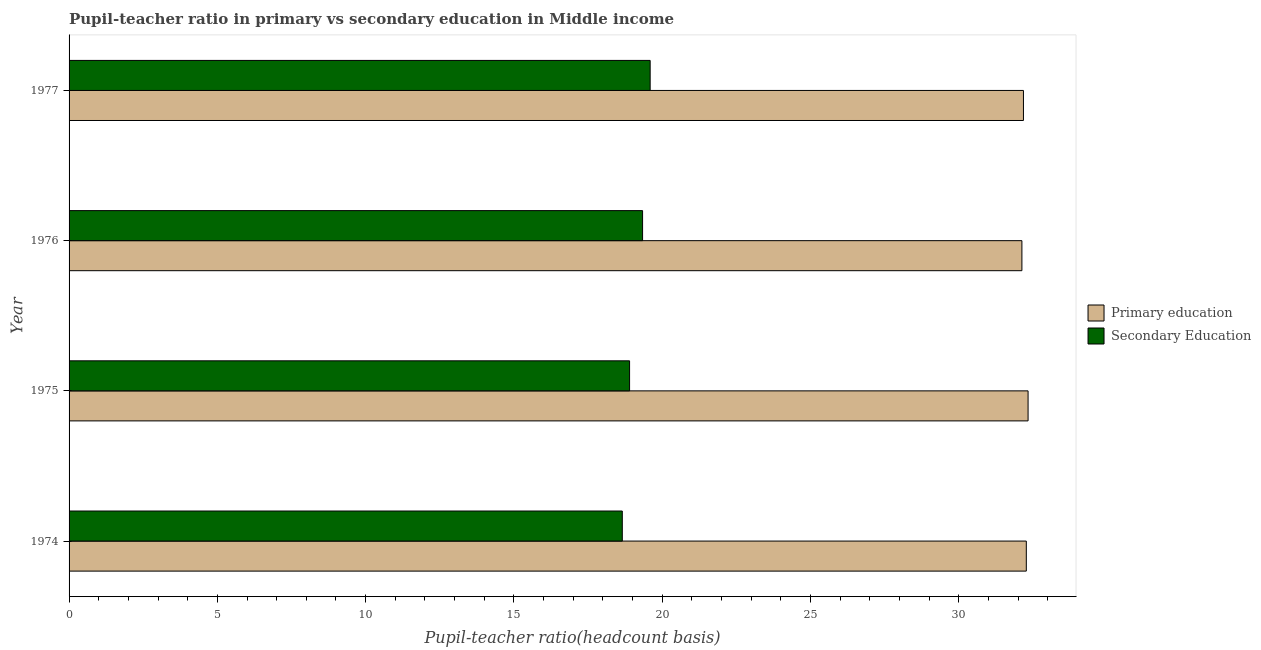How many different coloured bars are there?
Offer a terse response. 2. How many groups of bars are there?
Ensure brevity in your answer.  4. Are the number of bars per tick equal to the number of legend labels?
Your response must be concise. Yes. Are the number of bars on each tick of the Y-axis equal?
Provide a succinct answer. Yes. How many bars are there on the 3rd tick from the top?
Your response must be concise. 2. What is the label of the 3rd group of bars from the top?
Your response must be concise. 1975. What is the pupil-teacher ratio in primary education in 1977?
Ensure brevity in your answer.  32.18. Across all years, what is the maximum pupil-teacher ratio in primary education?
Your answer should be very brief. 32.34. Across all years, what is the minimum pupil-teacher ratio in primary education?
Provide a short and direct response. 32.13. In which year was the pupil teacher ratio on secondary education maximum?
Offer a very short reply. 1977. In which year was the pupil-teacher ratio in primary education minimum?
Make the answer very short. 1976. What is the total pupil teacher ratio on secondary education in the graph?
Provide a succinct answer. 76.49. What is the difference between the pupil teacher ratio on secondary education in 1975 and that in 1976?
Provide a succinct answer. -0.44. What is the difference between the pupil teacher ratio on secondary education in 1975 and the pupil-teacher ratio in primary education in 1974?
Your answer should be compact. -13.38. What is the average pupil-teacher ratio in primary education per year?
Give a very brief answer. 32.23. In the year 1976, what is the difference between the pupil-teacher ratio in primary education and pupil teacher ratio on secondary education?
Keep it short and to the point. 12.79. What is the difference between the highest and the second highest pupil teacher ratio on secondary education?
Provide a succinct answer. 0.26. What does the 2nd bar from the top in 1976 represents?
Offer a very short reply. Primary education. What does the 2nd bar from the bottom in 1975 represents?
Offer a terse response. Secondary Education. Are all the bars in the graph horizontal?
Provide a succinct answer. Yes. What is the difference between two consecutive major ticks on the X-axis?
Your answer should be compact. 5. Does the graph contain any zero values?
Your response must be concise. No. Does the graph contain grids?
Keep it short and to the point. No. How are the legend labels stacked?
Provide a succinct answer. Vertical. What is the title of the graph?
Give a very brief answer. Pupil-teacher ratio in primary vs secondary education in Middle income. Does "Under-five" appear as one of the legend labels in the graph?
Offer a terse response. No. What is the label or title of the X-axis?
Provide a succinct answer. Pupil-teacher ratio(headcount basis). What is the label or title of the Y-axis?
Provide a succinct answer. Year. What is the Pupil-teacher ratio(headcount basis) of Primary education in 1974?
Your answer should be very brief. 32.28. What is the Pupil-teacher ratio(headcount basis) in Secondary Education in 1974?
Make the answer very short. 18.66. What is the Pupil-teacher ratio(headcount basis) of Primary education in 1975?
Provide a succinct answer. 32.34. What is the Pupil-teacher ratio(headcount basis) in Secondary Education in 1975?
Provide a short and direct response. 18.9. What is the Pupil-teacher ratio(headcount basis) in Primary education in 1976?
Provide a succinct answer. 32.13. What is the Pupil-teacher ratio(headcount basis) in Secondary Education in 1976?
Keep it short and to the point. 19.34. What is the Pupil-teacher ratio(headcount basis) of Primary education in 1977?
Keep it short and to the point. 32.18. What is the Pupil-teacher ratio(headcount basis) in Secondary Education in 1977?
Your answer should be compact. 19.59. Across all years, what is the maximum Pupil-teacher ratio(headcount basis) of Primary education?
Give a very brief answer. 32.34. Across all years, what is the maximum Pupil-teacher ratio(headcount basis) in Secondary Education?
Your answer should be very brief. 19.59. Across all years, what is the minimum Pupil-teacher ratio(headcount basis) of Primary education?
Make the answer very short. 32.13. Across all years, what is the minimum Pupil-teacher ratio(headcount basis) of Secondary Education?
Ensure brevity in your answer.  18.66. What is the total Pupil-teacher ratio(headcount basis) of Primary education in the graph?
Your answer should be very brief. 128.93. What is the total Pupil-teacher ratio(headcount basis) of Secondary Education in the graph?
Ensure brevity in your answer.  76.49. What is the difference between the Pupil-teacher ratio(headcount basis) in Primary education in 1974 and that in 1975?
Make the answer very short. -0.06. What is the difference between the Pupil-teacher ratio(headcount basis) of Secondary Education in 1974 and that in 1975?
Your response must be concise. -0.25. What is the difference between the Pupil-teacher ratio(headcount basis) in Primary education in 1974 and that in 1976?
Keep it short and to the point. 0.15. What is the difference between the Pupil-teacher ratio(headcount basis) in Secondary Education in 1974 and that in 1976?
Provide a succinct answer. -0.68. What is the difference between the Pupil-teacher ratio(headcount basis) of Primary education in 1974 and that in 1977?
Ensure brevity in your answer.  0.1. What is the difference between the Pupil-teacher ratio(headcount basis) in Secondary Education in 1974 and that in 1977?
Make the answer very short. -0.94. What is the difference between the Pupil-teacher ratio(headcount basis) in Primary education in 1975 and that in 1976?
Make the answer very short. 0.21. What is the difference between the Pupil-teacher ratio(headcount basis) of Secondary Education in 1975 and that in 1976?
Your answer should be very brief. -0.44. What is the difference between the Pupil-teacher ratio(headcount basis) in Primary education in 1975 and that in 1977?
Ensure brevity in your answer.  0.16. What is the difference between the Pupil-teacher ratio(headcount basis) in Secondary Education in 1975 and that in 1977?
Provide a succinct answer. -0.69. What is the difference between the Pupil-teacher ratio(headcount basis) of Primary education in 1976 and that in 1977?
Ensure brevity in your answer.  -0.05. What is the difference between the Pupil-teacher ratio(headcount basis) of Secondary Education in 1976 and that in 1977?
Ensure brevity in your answer.  -0.26. What is the difference between the Pupil-teacher ratio(headcount basis) in Primary education in 1974 and the Pupil-teacher ratio(headcount basis) in Secondary Education in 1975?
Offer a terse response. 13.38. What is the difference between the Pupil-teacher ratio(headcount basis) in Primary education in 1974 and the Pupil-teacher ratio(headcount basis) in Secondary Education in 1976?
Provide a succinct answer. 12.94. What is the difference between the Pupil-teacher ratio(headcount basis) in Primary education in 1974 and the Pupil-teacher ratio(headcount basis) in Secondary Education in 1977?
Your response must be concise. 12.68. What is the difference between the Pupil-teacher ratio(headcount basis) in Primary education in 1975 and the Pupil-teacher ratio(headcount basis) in Secondary Education in 1976?
Keep it short and to the point. 13. What is the difference between the Pupil-teacher ratio(headcount basis) in Primary education in 1975 and the Pupil-teacher ratio(headcount basis) in Secondary Education in 1977?
Offer a very short reply. 12.74. What is the difference between the Pupil-teacher ratio(headcount basis) of Primary education in 1976 and the Pupil-teacher ratio(headcount basis) of Secondary Education in 1977?
Offer a terse response. 12.54. What is the average Pupil-teacher ratio(headcount basis) of Primary education per year?
Offer a very short reply. 32.23. What is the average Pupil-teacher ratio(headcount basis) of Secondary Education per year?
Your answer should be very brief. 19.12. In the year 1974, what is the difference between the Pupil-teacher ratio(headcount basis) of Primary education and Pupil-teacher ratio(headcount basis) of Secondary Education?
Give a very brief answer. 13.62. In the year 1975, what is the difference between the Pupil-teacher ratio(headcount basis) in Primary education and Pupil-teacher ratio(headcount basis) in Secondary Education?
Provide a succinct answer. 13.44. In the year 1976, what is the difference between the Pupil-teacher ratio(headcount basis) in Primary education and Pupil-teacher ratio(headcount basis) in Secondary Education?
Provide a succinct answer. 12.79. In the year 1977, what is the difference between the Pupil-teacher ratio(headcount basis) of Primary education and Pupil-teacher ratio(headcount basis) of Secondary Education?
Give a very brief answer. 12.59. What is the ratio of the Pupil-teacher ratio(headcount basis) of Primary education in 1974 to that in 1975?
Your response must be concise. 1. What is the ratio of the Pupil-teacher ratio(headcount basis) in Primary education in 1974 to that in 1976?
Make the answer very short. 1. What is the ratio of the Pupil-teacher ratio(headcount basis) of Secondary Education in 1974 to that in 1976?
Offer a very short reply. 0.96. What is the ratio of the Pupil-teacher ratio(headcount basis) of Secondary Education in 1974 to that in 1977?
Ensure brevity in your answer.  0.95. What is the ratio of the Pupil-teacher ratio(headcount basis) of Secondary Education in 1975 to that in 1976?
Provide a short and direct response. 0.98. What is the ratio of the Pupil-teacher ratio(headcount basis) of Primary education in 1975 to that in 1977?
Keep it short and to the point. 1. What is the ratio of the Pupil-teacher ratio(headcount basis) in Secondary Education in 1975 to that in 1977?
Your answer should be compact. 0.96. What is the ratio of the Pupil-teacher ratio(headcount basis) of Secondary Education in 1976 to that in 1977?
Make the answer very short. 0.99. What is the difference between the highest and the second highest Pupil-teacher ratio(headcount basis) of Primary education?
Ensure brevity in your answer.  0.06. What is the difference between the highest and the second highest Pupil-teacher ratio(headcount basis) of Secondary Education?
Provide a succinct answer. 0.26. What is the difference between the highest and the lowest Pupil-teacher ratio(headcount basis) in Primary education?
Keep it short and to the point. 0.21. What is the difference between the highest and the lowest Pupil-teacher ratio(headcount basis) of Secondary Education?
Your answer should be compact. 0.94. 